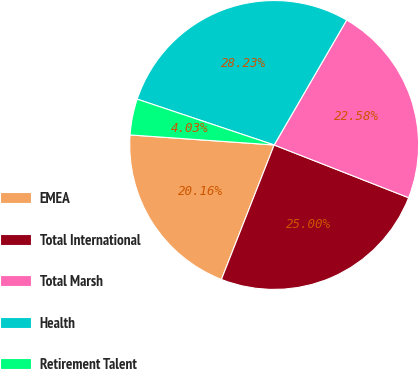Convert chart to OTSL. <chart><loc_0><loc_0><loc_500><loc_500><pie_chart><fcel>EMEA<fcel>Total International<fcel>Total Marsh<fcel>Health<fcel>Retirement Talent<nl><fcel>20.16%<fcel>25.0%<fcel>22.58%<fcel>28.23%<fcel>4.03%<nl></chart> 